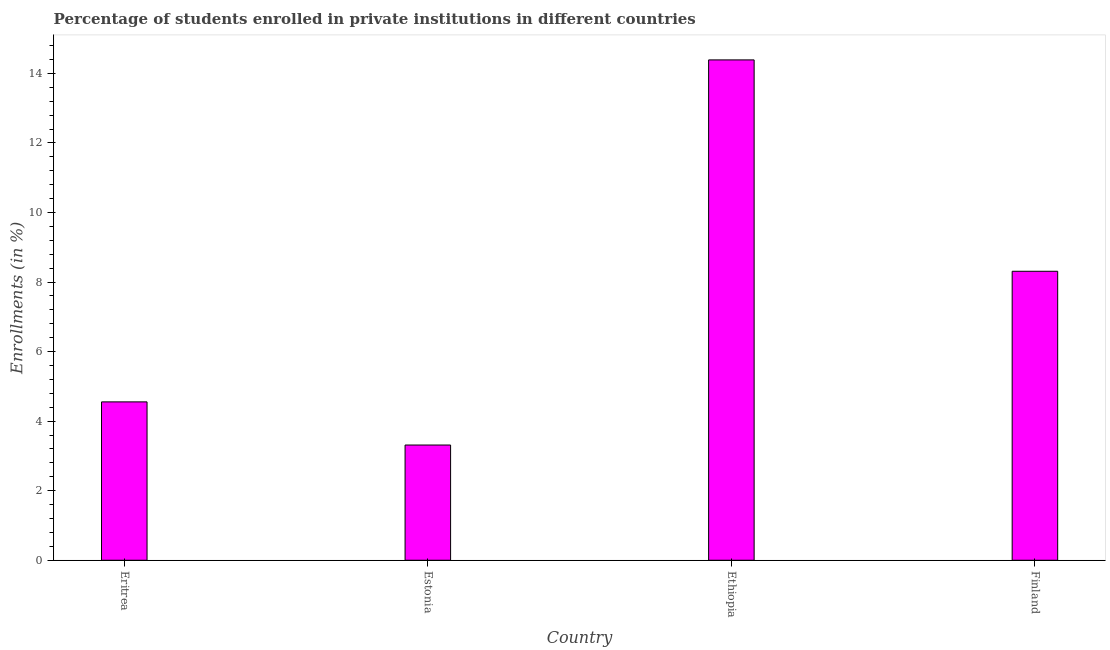Does the graph contain any zero values?
Offer a terse response. No. Does the graph contain grids?
Provide a short and direct response. No. What is the title of the graph?
Give a very brief answer. Percentage of students enrolled in private institutions in different countries. What is the label or title of the Y-axis?
Provide a succinct answer. Enrollments (in %). What is the enrollments in private institutions in Finland?
Give a very brief answer. 8.31. Across all countries, what is the maximum enrollments in private institutions?
Provide a short and direct response. 14.39. Across all countries, what is the minimum enrollments in private institutions?
Keep it short and to the point. 3.31. In which country was the enrollments in private institutions maximum?
Provide a short and direct response. Ethiopia. In which country was the enrollments in private institutions minimum?
Give a very brief answer. Estonia. What is the sum of the enrollments in private institutions?
Provide a short and direct response. 30.56. What is the difference between the enrollments in private institutions in Eritrea and Ethiopia?
Provide a succinct answer. -9.83. What is the average enrollments in private institutions per country?
Your answer should be very brief. 7.64. What is the median enrollments in private institutions?
Give a very brief answer. 6.43. In how many countries, is the enrollments in private institutions greater than 0.4 %?
Keep it short and to the point. 4. What is the ratio of the enrollments in private institutions in Eritrea to that in Ethiopia?
Provide a succinct answer. 0.32. Is the enrollments in private institutions in Estonia less than that in Finland?
Give a very brief answer. Yes. Is the difference between the enrollments in private institutions in Estonia and Ethiopia greater than the difference between any two countries?
Give a very brief answer. Yes. What is the difference between the highest and the second highest enrollments in private institutions?
Give a very brief answer. 6.08. What is the difference between the highest and the lowest enrollments in private institutions?
Provide a succinct answer. 11.07. In how many countries, is the enrollments in private institutions greater than the average enrollments in private institutions taken over all countries?
Give a very brief answer. 2. Are all the bars in the graph horizontal?
Ensure brevity in your answer.  No. How many countries are there in the graph?
Give a very brief answer. 4. Are the values on the major ticks of Y-axis written in scientific E-notation?
Provide a short and direct response. No. What is the Enrollments (in %) in Eritrea?
Provide a succinct answer. 4.55. What is the Enrollments (in %) in Estonia?
Provide a succinct answer. 3.31. What is the Enrollments (in %) of Ethiopia?
Ensure brevity in your answer.  14.39. What is the Enrollments (in %) of Finland?
Make the answer very short. 8.31. What is the difference between the Enrollments (in %) in Eritrea and Estonia?
Give a very brief answer. 1.24. What is the difference between the Enrollments (in %) in Eritrea and Ethiopia?
Ensure brevity in your answer.  -9.83. What is the difference between the Enrollments (in %) in Eritrea and Finland?
Make the answer very short. -3.76. What is the difference between the Enrollments (in %) in Estonia and Ethiopia?
Provide a succinct answer. -11.07. What is the difference between the Enrollments (in %) in Estonia and Finland?
Your answer should be very brief. -5. What is the difference between the Enrollments (in %) in Ethiopia and Finland?
Make the answer very short. 6.08. What is the ratio of the Enrollments (in %) in Eritrea to that in Estonia?
Provide a short and direct response. 1.37. What is the ratio of the Enrollments (in %) in Eritrea to that in Ethiopia?
Offer a very short reply. 0.32. What is the ratio of the Enrollments (in %) in Eritrea to that in Finland?
Offer a very short reply. 0.55. What is the ratio of the Enrollments (in %) in Estonia to that in Ethiopia?
Offer a terse response. 0.23. What is the ratio of the Enrollments (in %) in Estonia to that in Finland?
Make the answer very short. 0.4. What is the ratio of the Enrollments (in %) in Ethiopia to that in Finland?
Provide a short and direct response. 1.73. 